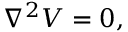Convert formula to latex. <formula><loc_0><loc_0><loc_500><loc_500>\nabla ^ { 2 } V = 0 ,</formula> 